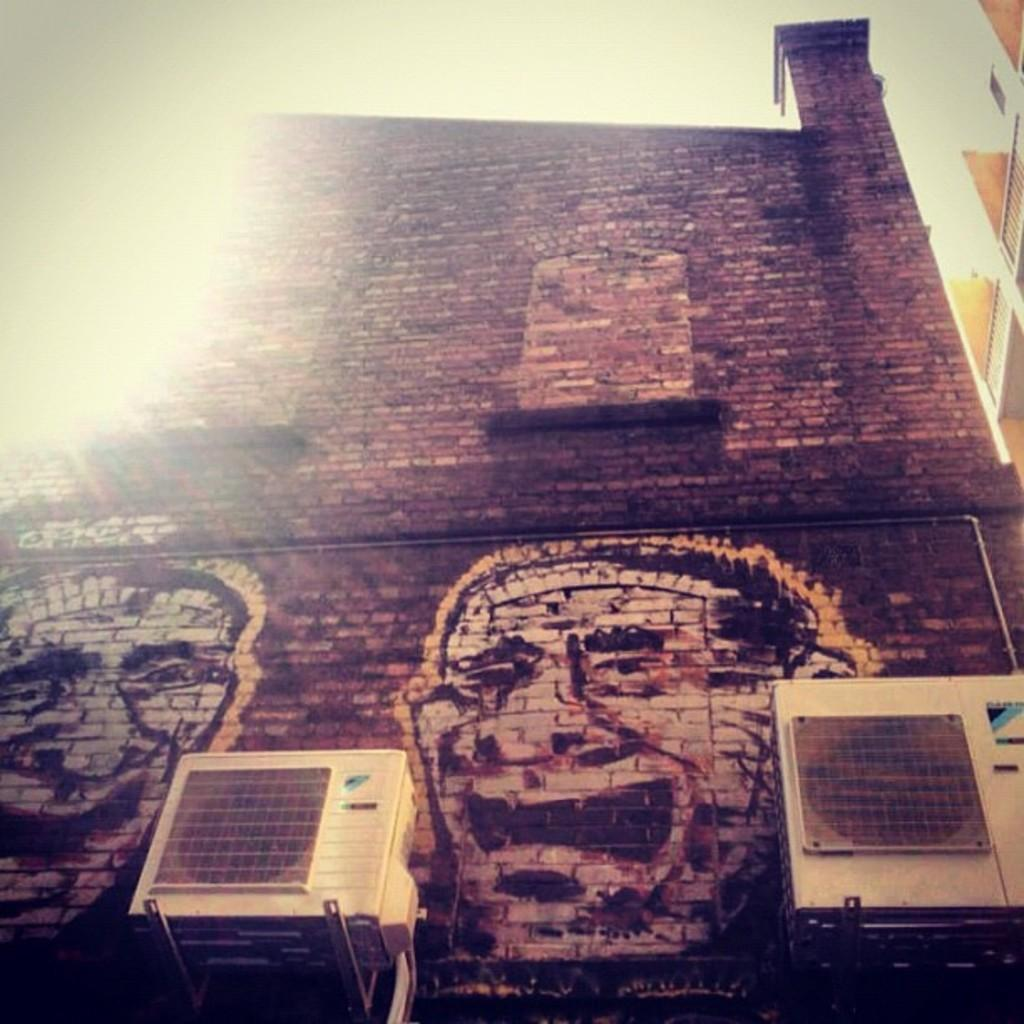What type of structure is present in the image? There is a building in the image. What decorative element can be seen on the building? There is a wall painting on the building. What type of equipment is visible in the image? There are two outdoor units in the image. What is visible at the top of the image? The sky is visible at the top of the image. What type of land is depicted in the wall painting on the building? There is no land depicted in the wall painting on the building; the wall painting is not described in the facts provided. 